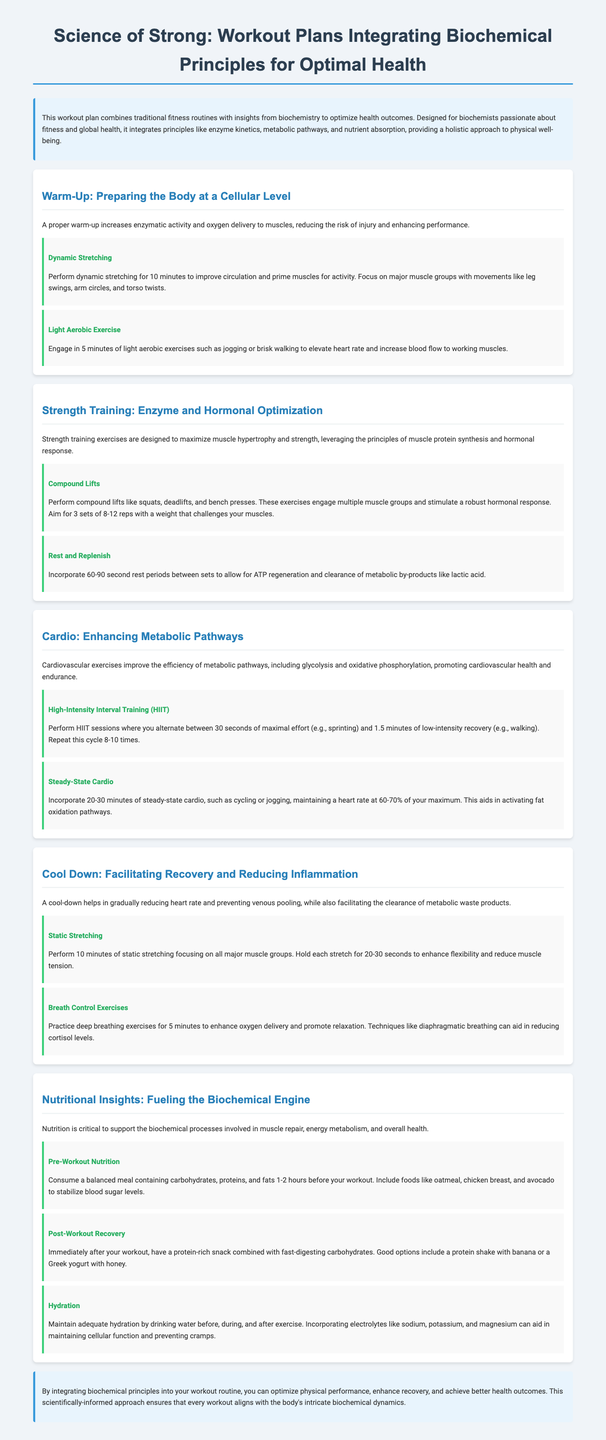what is the title of the document? The title is presented in the header of the document.
Answer: Science of Strong: Workout Plans Integrating Biochemical Principles for Optimal Health how long should you perform dynamic stretching? The duration for dynamic stretching is specified in the warm-up section.
Answer: 10 minutes what type of exercise should be performed after compound lifts? The activity following compound lifts is mentioned in the strength training section.
Answer: Rest and Replenish how many cycles are recommended for HIIT sessions? The number of cycles for HIIT sessions is mentioned in the cardio section.
Answer: 8-10 times what should you focus on during the cool-down period? The cool-down section emphasizes key activities to focus on.
Answer: Facilitating Recovery and Reducing Inflammation which nutrient composition is suggested for pre-workout nutrition? The guideline for pre-workout nutrition specifies the necessary nutrient composition.
Answer: Carbohydrates, proteins, and fats what duration is recommended for steady-state cardio? The recommended duration for steady-state cardio is stated in the cardio section.
Answer: 20-30 minutes which exercises are suggested for maintaining flexibility during cool down? The specific exercises for maintaining flexibility are detailed in the cool-down section.
Answer: Static Stretching 